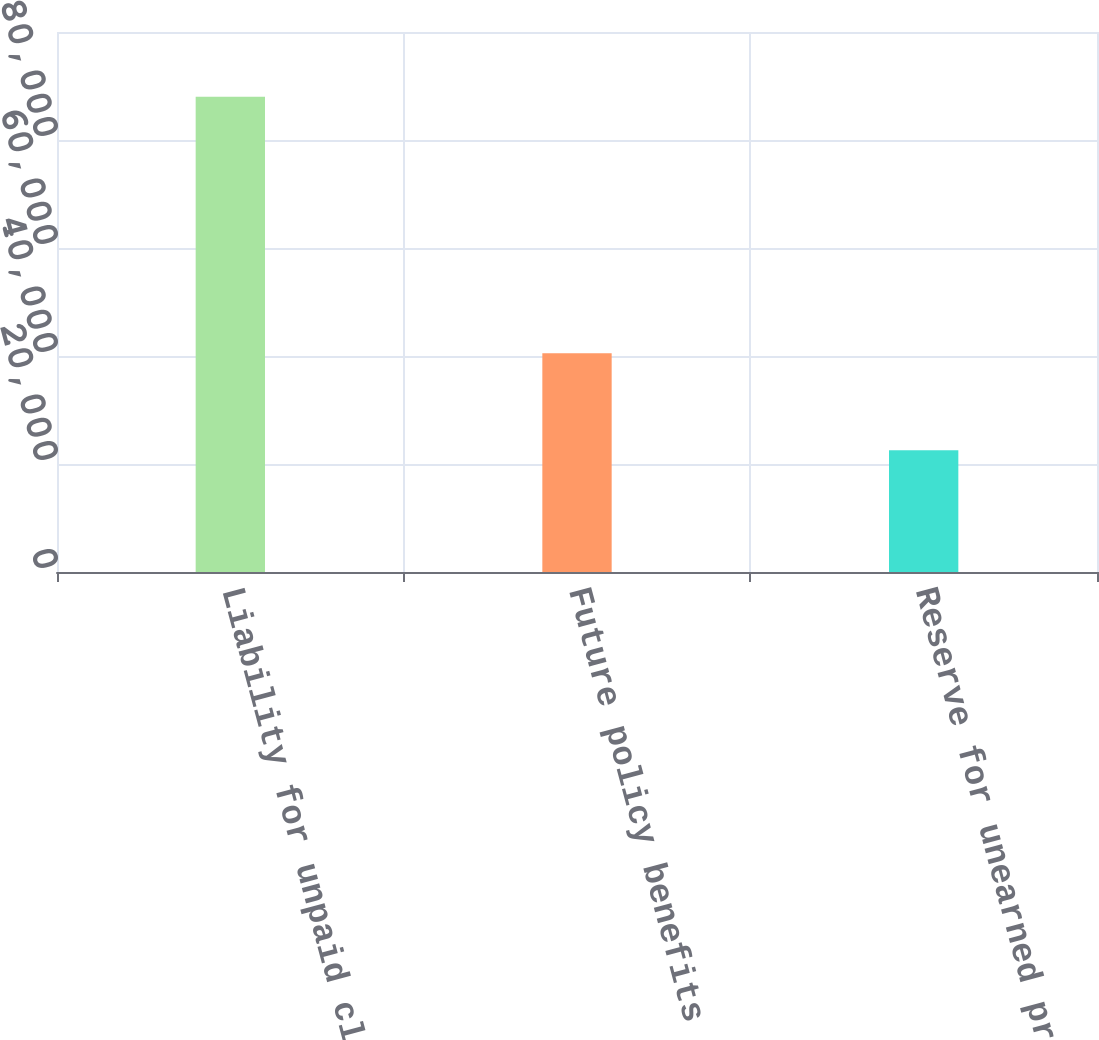Convert chart to OTSL. <chart><loc_0><loc_0><loc_500><loc_500><bar_chart><fcel>Liability for unpaid claims<fcel>Future policy benefits for<fcel>Reserve for unearned premiums<nl><fcel>87991<fcel>40523<fcel>22537<nl></chart> 